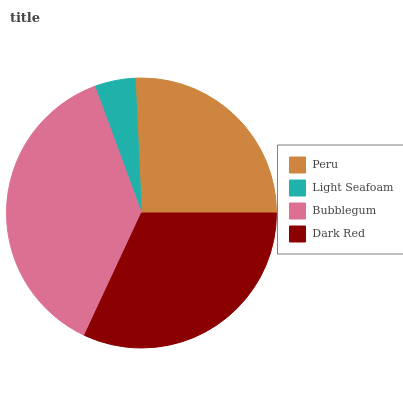Is Light Seafoam the minimum?
Answer yes or no. Yes. Is Bubblegum the maximum?
Answer yes or no. Yes. Is Bubblegum the minimum?
Answer yes or no. No. Is Light Seafoam the maximum?
Answer yes or no. No. Is Bubblegum greater than Light Seafoam?
Answer yes or no. Yes. Is Light Seafoam less than Bubblegum?
Answer yes or no. Yes. Is Light Seafoam greater than Bubblegum?
Answer yes or no. No. Is Bubblegum less than Light Seafoam?
Answer yes or no. No. Is Dark Red the high median?
Answer yes or no. Yes. Is Peru the low median?
Answer yes or no. Yes. Is Bubblegum the high median?
Answer yes or no. No. Is Light Seafoam the low median?
Answer yes or no. No. 